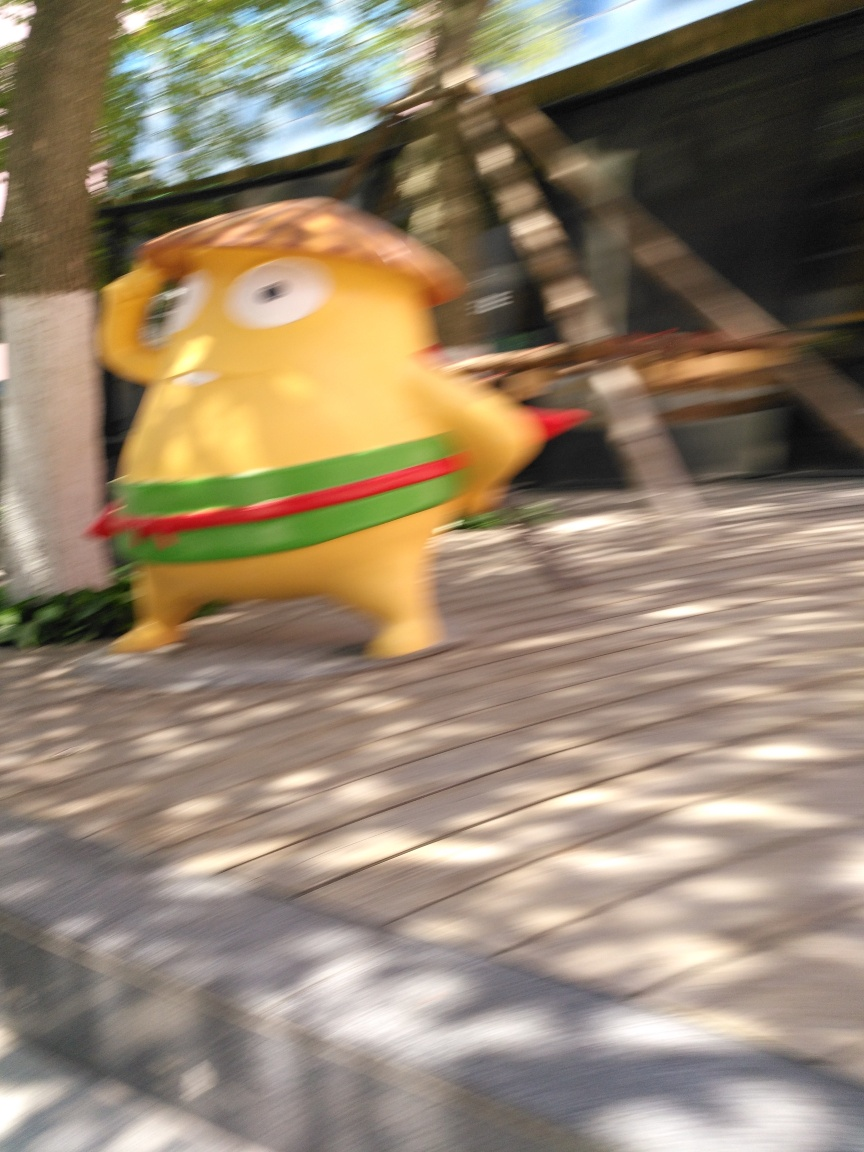Is there any noise present in this image? The image appears to have motion blur, which is a form of visual distortion created by the movement of the subject or the camera during exposure. It gives the photo a sense of speed and dynamic action but also makes the details of the subject less sharp. 